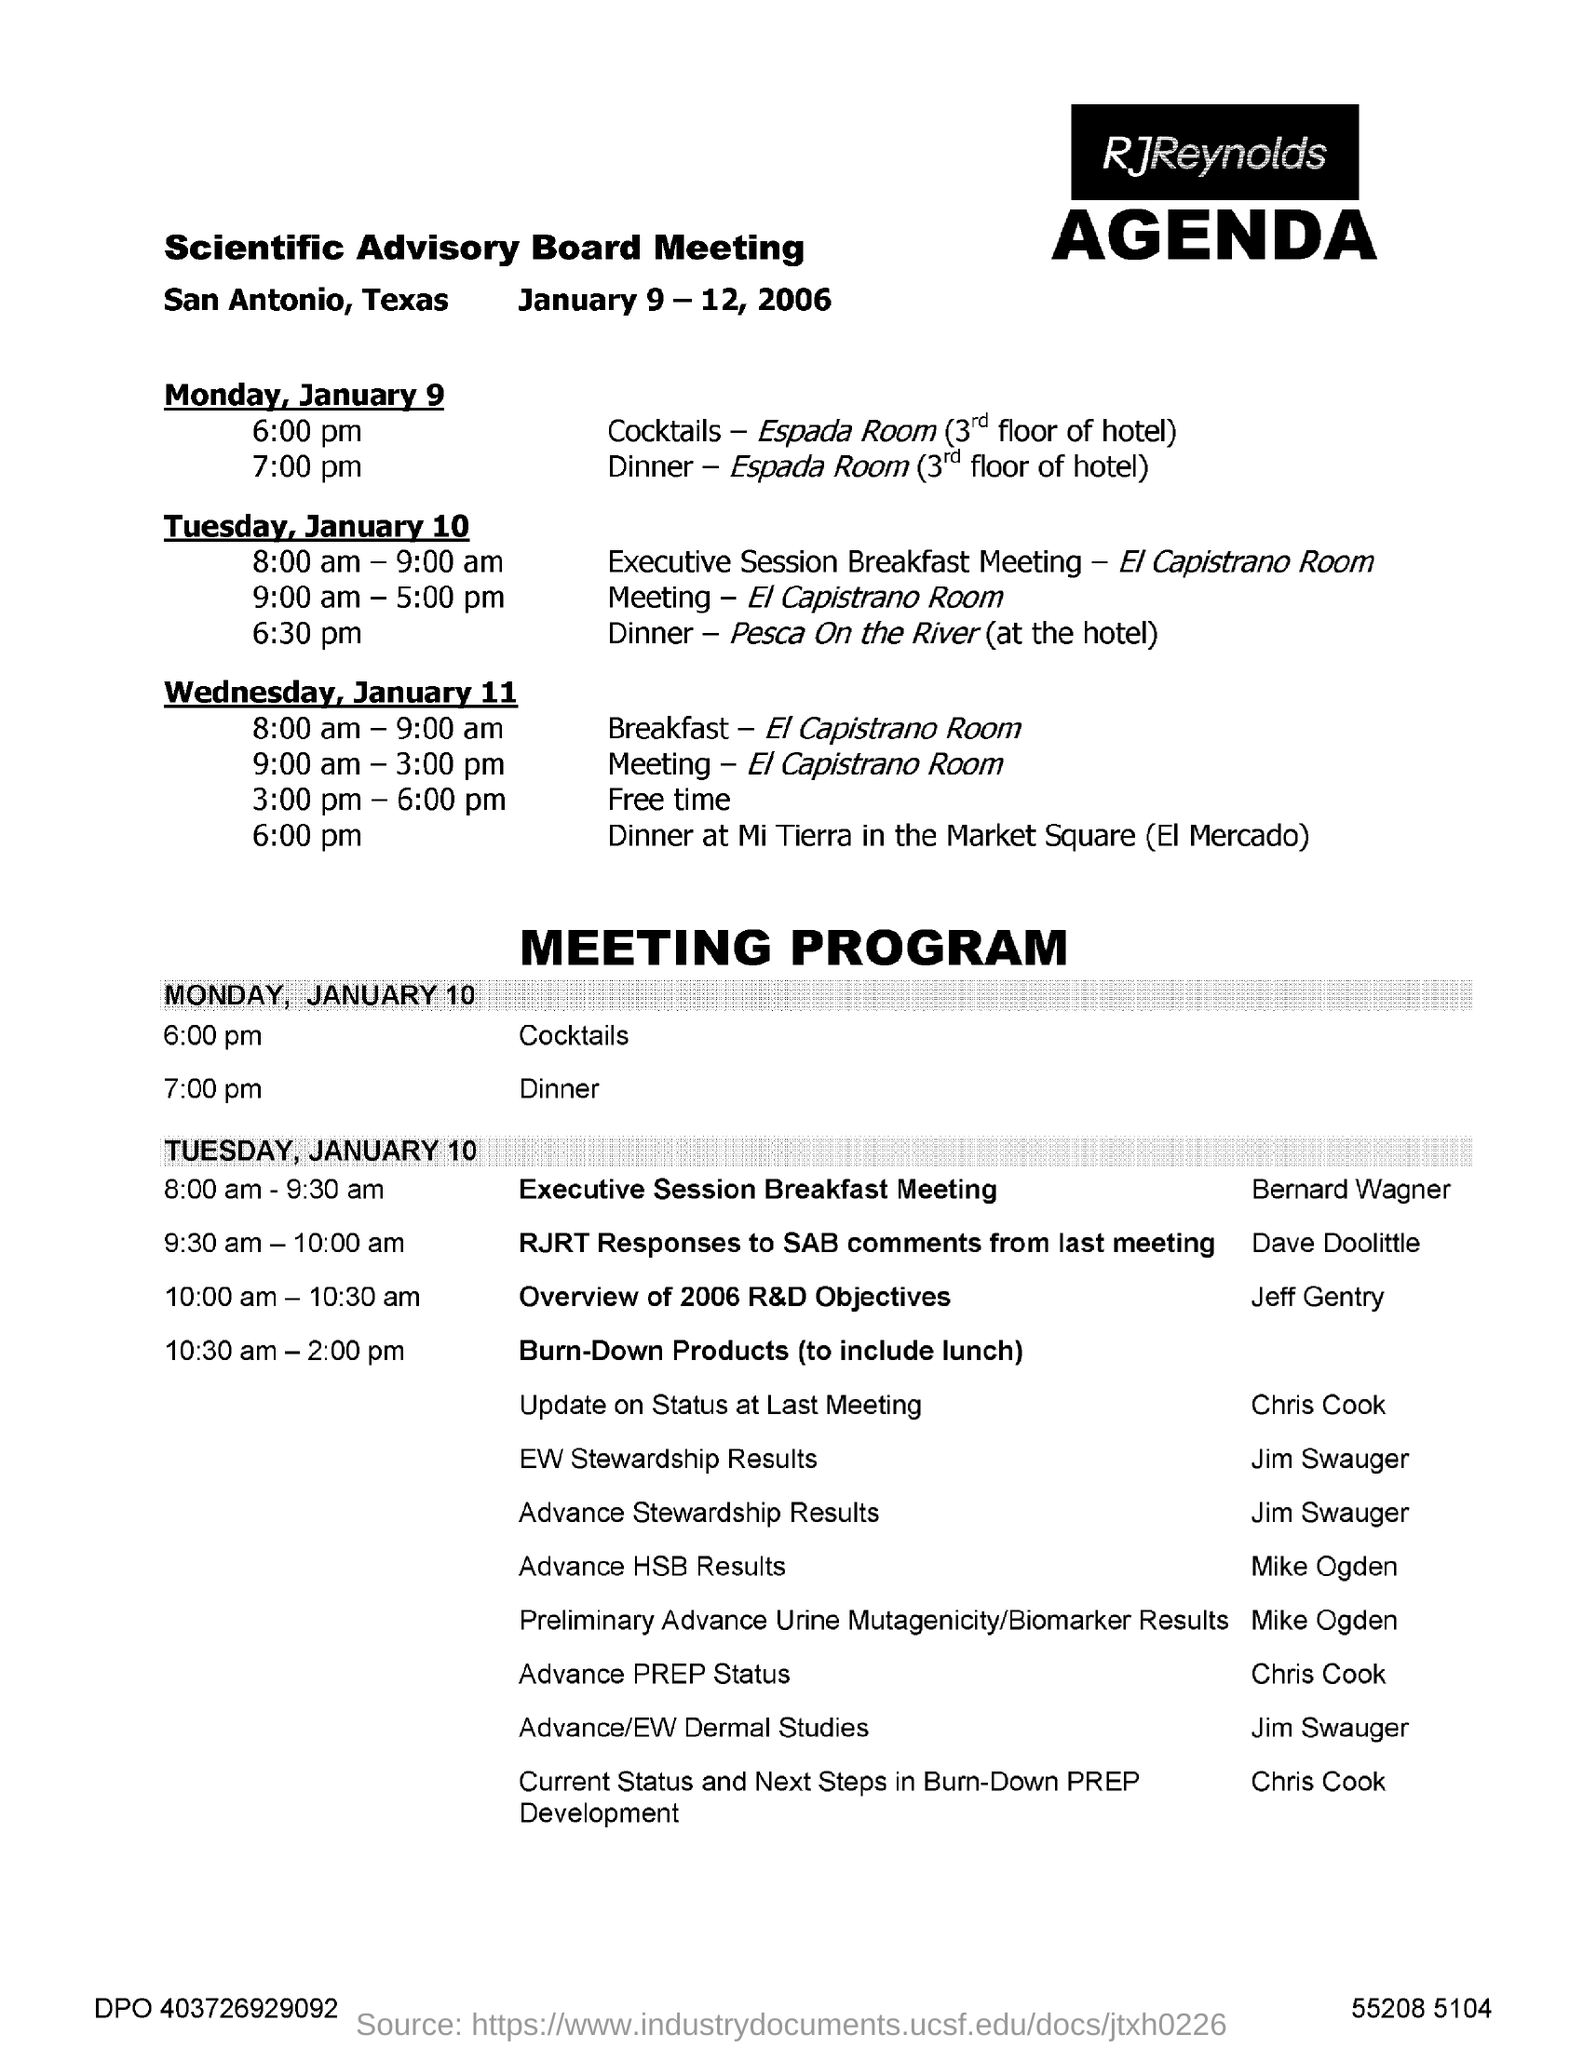Identify some key points in this picture. The Scientific Advisory Board meeting is scheduled to take place from January 9 to 12, 2006. The Scientific Advisory Board is currently holding its meetings in San Antonio, Texas. 